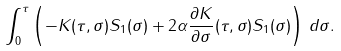Convert formula to latex. <formula><loc_0><loc_0><loc_500><loc_500>\int _ { 0 } ^ { \tau } \left ( - K ( \tau , \sigma ) S _ { 1 } ( \sigma ) + 2 \alpha \frac { \partial K } { \partial \sigma } ( \tau , \sigma ) S _ { 1 } ( \sigma ) \right ) \, d \sigma .</formula> 